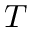Convert formula to latex. <formula><loc_0><loc_0><loc_500><loc_500>T</formula> 